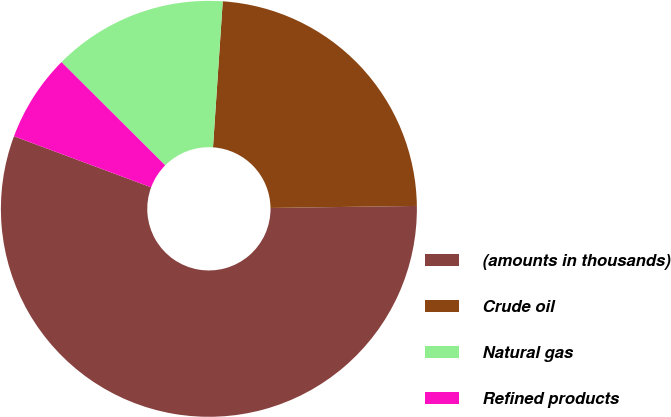Convert chart. <chart><loc_0><loc_0><loc_500><loc_500><pie_chart><fcel>(amounts in thousands)<fcel>Crude oil<fcel>Natural gas<fcel>Refined products<nl><fcel>55.9%<fcel>23.72%<fcel>13.6%<fcel>6.79%<nl></chart> 